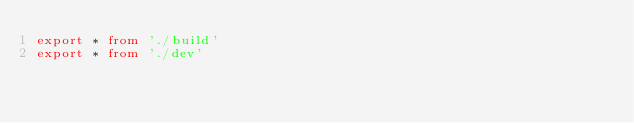<code> <loc_0><loc_0><loc_500><loc_500><_TypeScript_>export * from './build'
export * from './dev'
</code> 